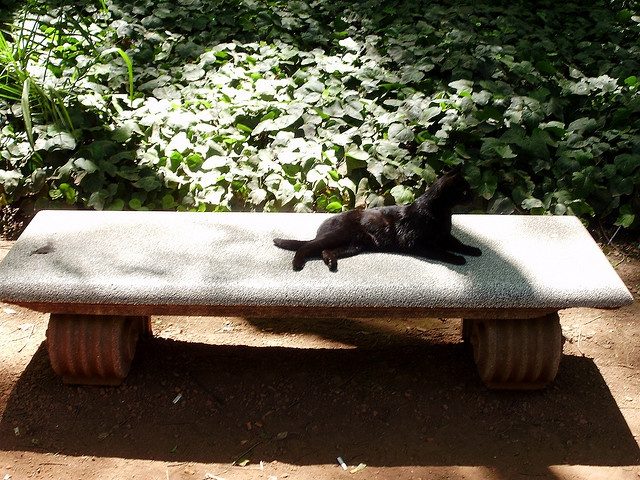Describe the objects in this image and their specific colors. I can see bench in black, white, maroon, and gray tones, cat in black, ivory, gray, and darkgray tones, and potted plant in black, ivory, darkgreen, and beige tones in this image. 